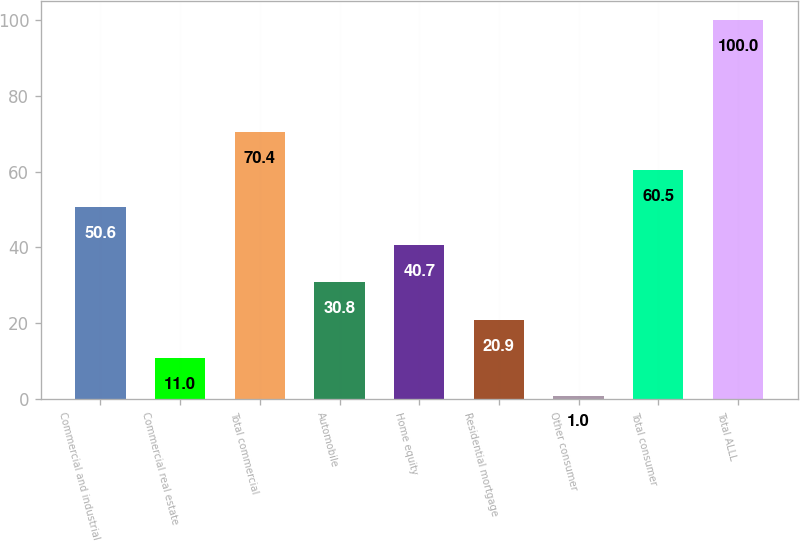<chart> <loc_0><loc_0><loc_500><loc_500><bar_chart><fcel>Commercial and industrial<fcel>Commercial real estate<fcel>Total commercial<fcel>Automobile<fcel>Home equity<fcel>Residential mortgage<fcel>Other consumer<fcel>Total consumer<fcel>Total ALLL<nl><fcel>50.6<fcel>11<fcel>70.4<fcel>30.8<fcel>40.7<fcel>20.9<fcel>1<fcel>60.5<fcel>100<nl></chart> 